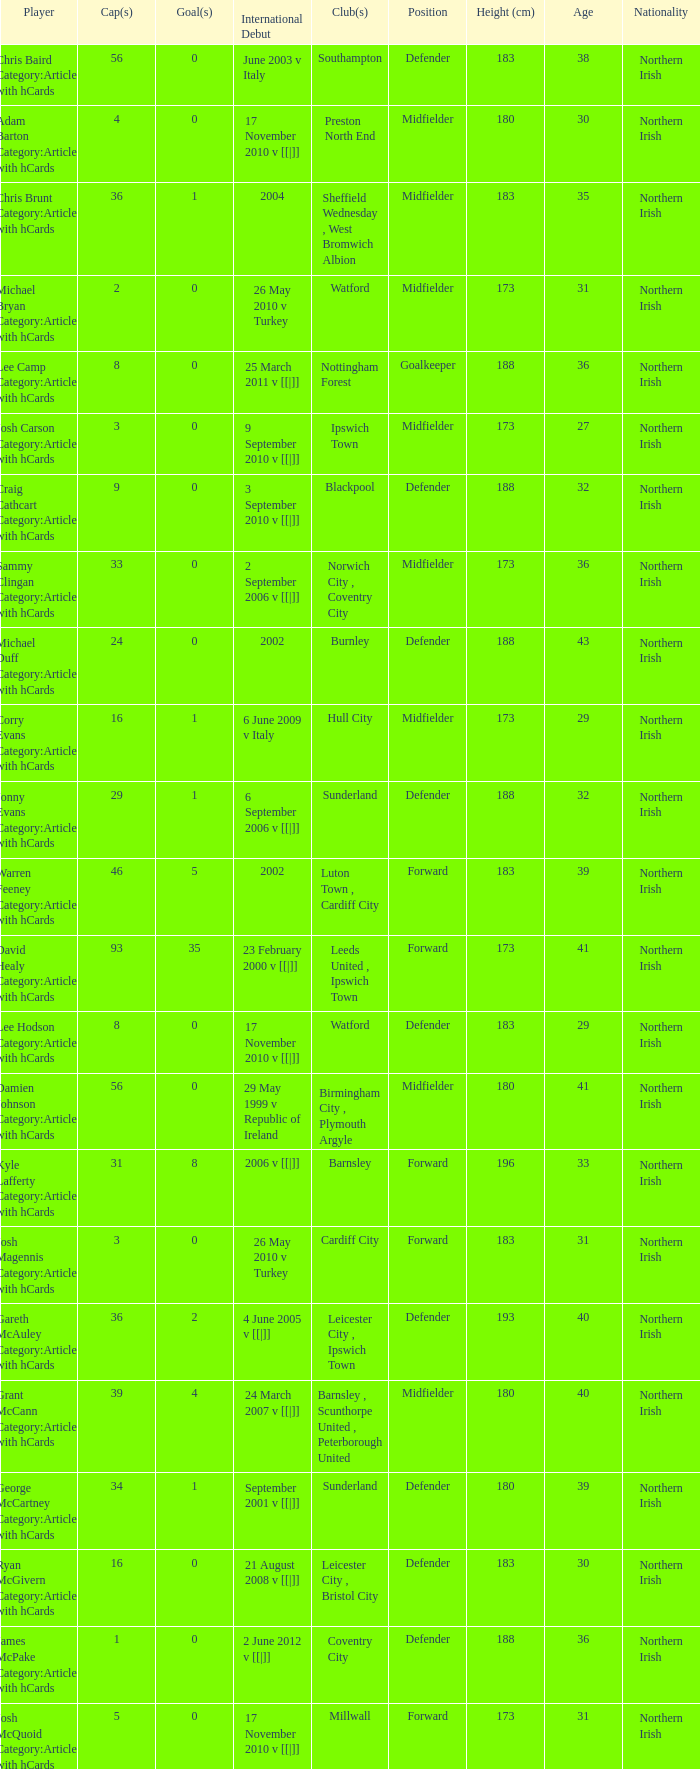How many caps figures for the Doncaster Rovers? 1.0. 